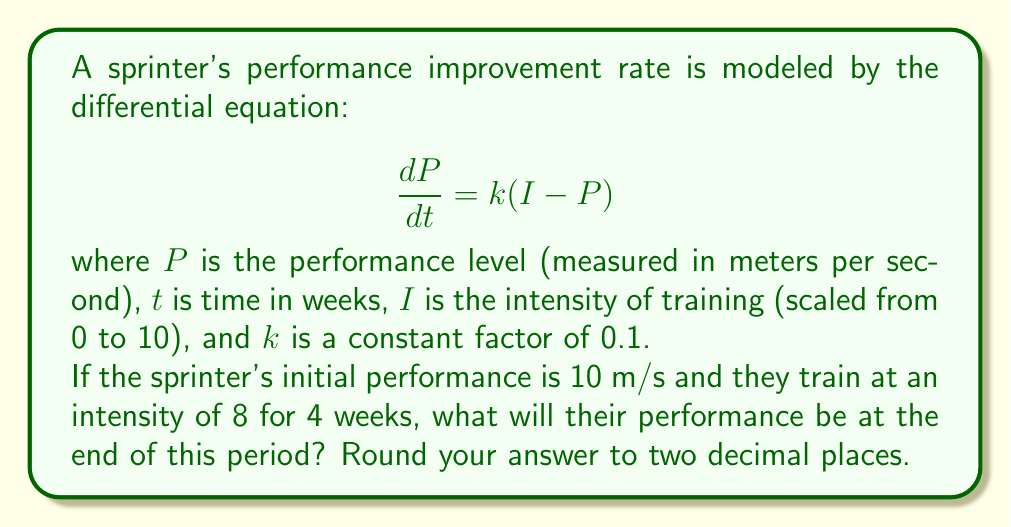Help me with this question. To solve this problem, we need to use the given differential equation and initial conditions:

1) The differential equation is: $\frac{dP}{dt} = k(I-P)$

2) Given:
   - $k = 0.1$
   - $I = 8$ (training intensity)
   - $P_0 = 10$ m/s (initial performance)
   - $t = 4$ weeks

3) This is a first-order linear differential equation. The general solution is:

   $P(t) = I + (P_0 - I)e^{-kt}$

4) Substituting the values:

   $P(t) = 8 + (10 - 8)e^{-0.1t}$
   
   $P(t) = 8 + 2e^{-0.1t}$

5) To find the performance after 4 weeks, we substitute $t = 4$:

   $P(4) = 8 + 2e^{-0.1(4)}$
   
   $P(4) = 8 + 2e^{-0.4}$
   
   $P(4) = 8 + 2(0.67032)$
   
   $P(4) = 8 + 1.34064$
   
   $P(4) = 9.34064$ m/s

6) Rounding to two decimal places:

   $P(4) \approx 9.34$ m/s
Answer: 9.34 m/s 